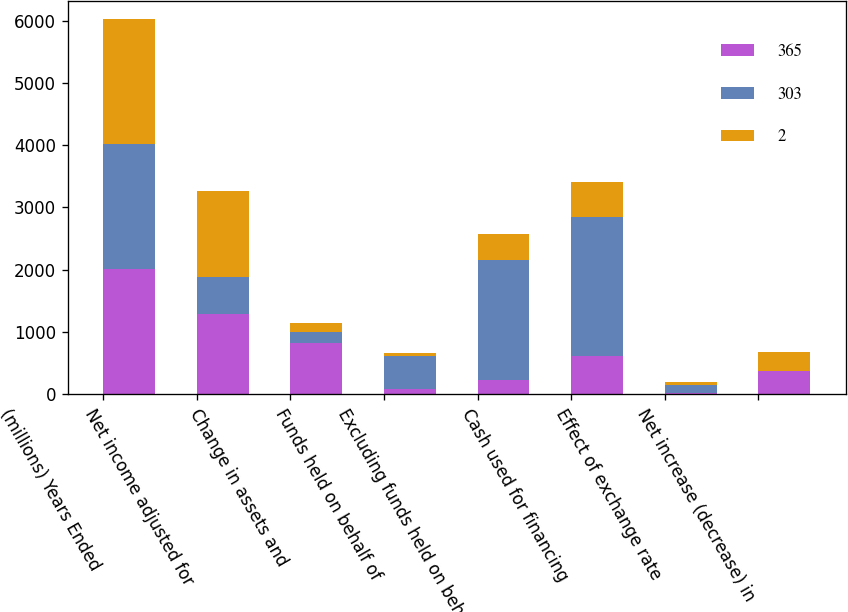<chart> <loc_0><loc_0><loc_500><loc_500><stacked_bar_chart><ecel><fcel>(millions) Years Ended<fcel>Net income adjusted for<fcel>Change in assets and<fcel>Funds held on behalf of<fcel>Excluding funds held on behalf<fcel>Cash used for financing<fcel>Effect of exchange rate<fcel>Net increase (decrease) in<nl><fcel>365<fcel>2009<fcel>1290<fcel>825<fcel>90<fcel>229<fcel>617<fcel>16<fcel>365<nl><fcel>303<fcel>2008<fcel>601<fcel>167<fcel>525<fcel>1929<fcel>2235<fcel>130<fcel>2<nl><fcel>2<fcel>2007<fcel>1366<fcel>153<fcel>50<fcel>413<fcel>553<fcel>56<fcel>303<nl></chart> 